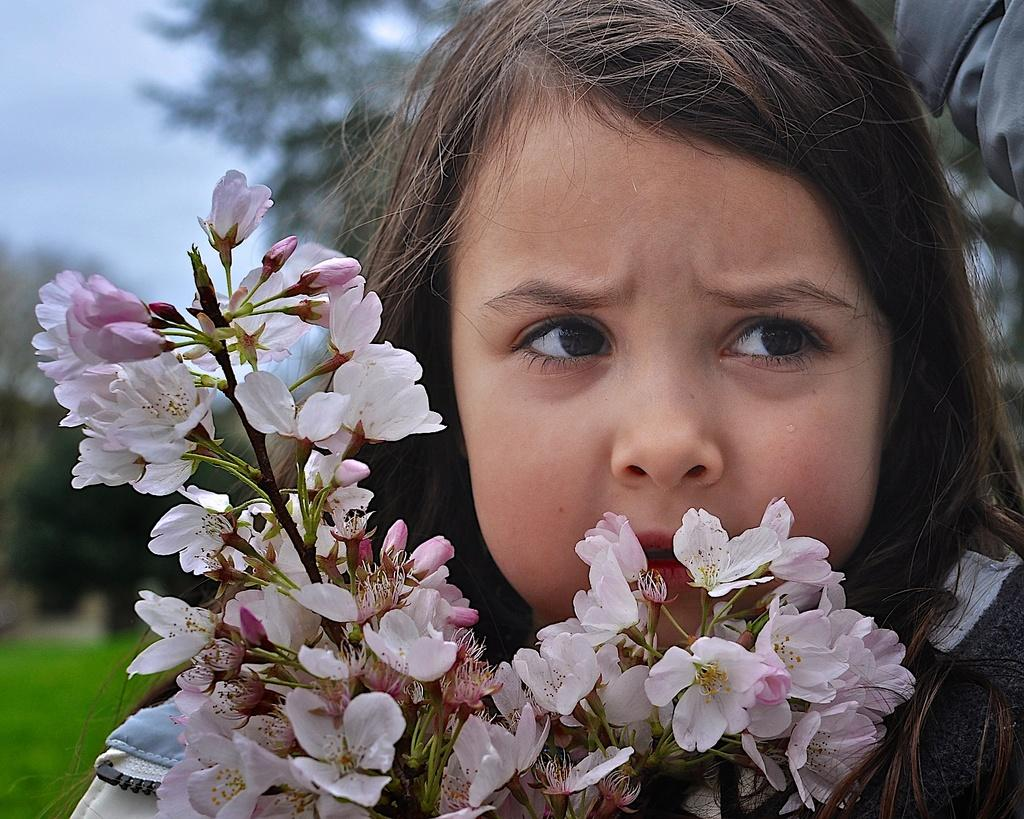Who is the main subject in the image? There is a girl in the center of the image. What can be seen besides the girl in the image? There are flowers in the image. What is visible in the background of the image? There are trees and grass in the background of the image. How long does it take for the insect to crawl across the girl's face in the image? There is no insect present in the image, so it is not possible to determine how long it would take for an insect to crawl across the girl's face. 